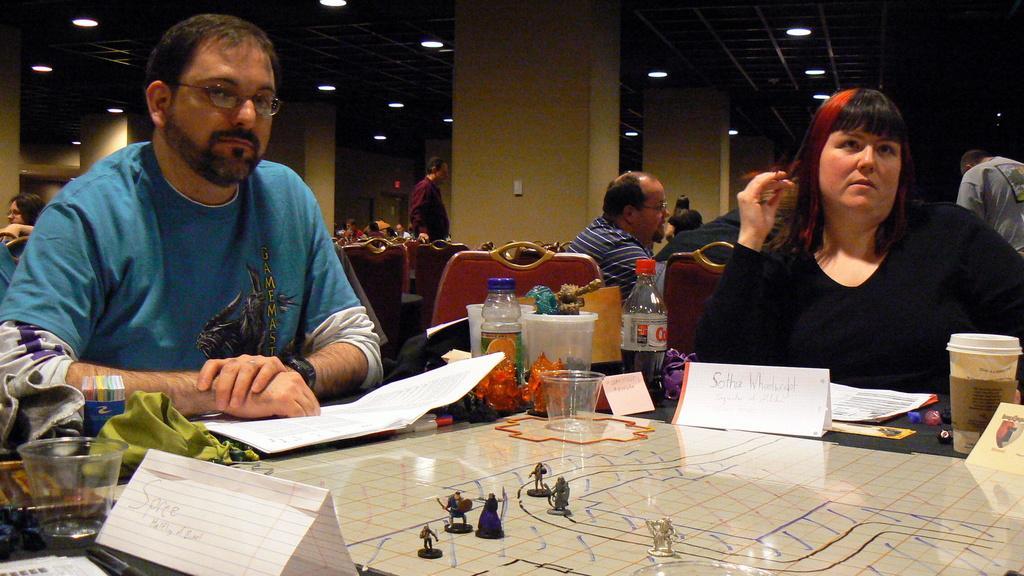Could you give a brief overview of what you see in this image? A man and woman are sitting at a table. There is map like game on the table. There are glasses ,bottles and few other items on the table. There are some other people sitting behind them. There are lights on to the roof. 